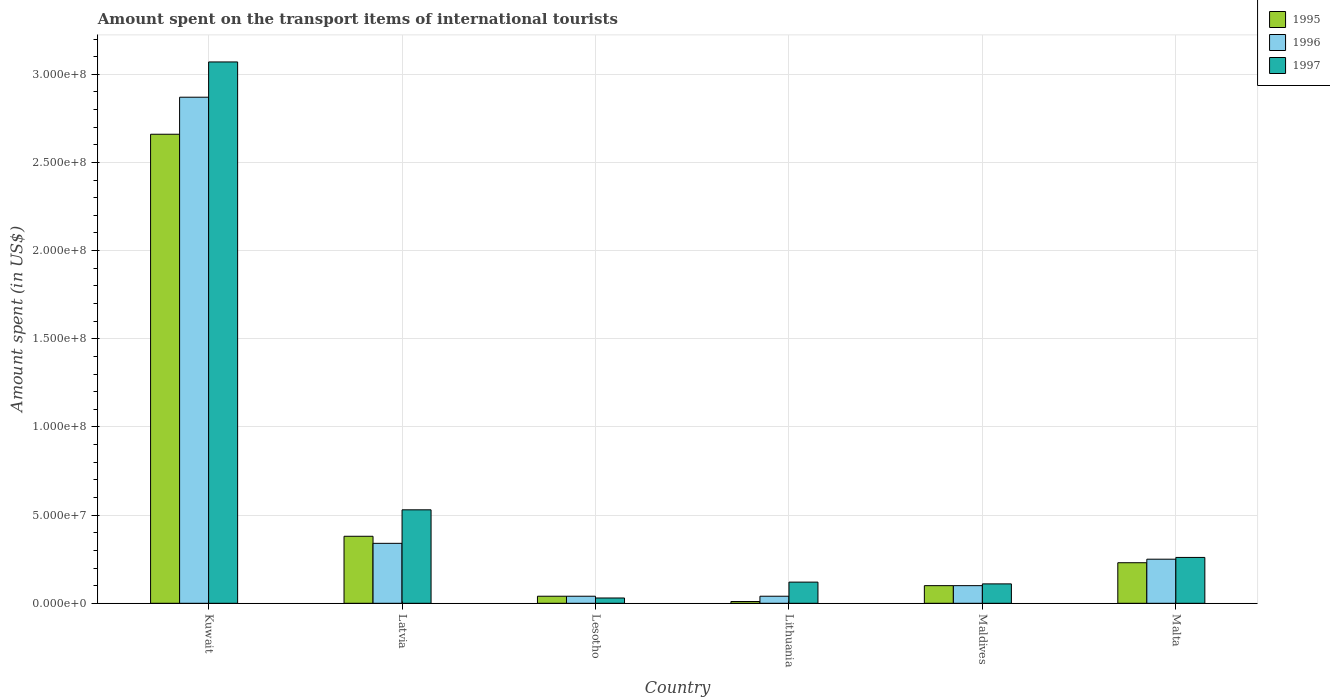How many different coloured bars are there?
Offer a very short reply. 3. How many groups of bars are there?
Your response must be concise. 6. Are the number of bars on each tick of the X-axis equal?
Give a very brief answer. Yes. How many bars are there on the 5th tick from the left?
Keep it short and to the point. 3. What is the label of the 6th group of bars from the left?
Provide a short and direct response. Malta. Across all countries, what is the maximum amount spent on the transport items of international tourists in 1995?
Make the answer very short. 2.66e+08. Across all countries, what is the minimum amount spent on the transport items of international tourists in 1997?
Keep it short and to the point. 3.00e+06. In which country was the amount spent on the transport items of international tourists in 1996 maximum?
Provide a succinct answer. Kuwait. In which country was the amount spent on the transport items of international tourists in 1995 minimum?
Offer a very short reply. Lithuania. What is the total amount spent on the transport items of international tourists in 1996 in the graph?
Provide a succinct answer. 3.64e+08. What is the difference between the amount spent on the transport items of international tourists in 1995 in Lithuania and that in Maldives?
Give a very brief answer. -9.00e+06. What is the difference between the amount spent on the transport items of international tourists in 1995 in Latvia and the amount spent on the transport items of international tourists in 1996 in Kuwait?
Provide a succinct answer. -2.49e+08. What is the average amount spent on the transport items of international tourists in 1995 per country?
Your answer should be very brief. 5.70e+07. What is the difference between the amount spent on the transport items of international tourists of/in 1996 and amount spent on the transport items of international tourists of/in 1995 in Maldives?
Your answer should be compact. 0. In how many countries, is the amount spent on the transport items of international tourists in 1997 greater than 190000000 US$?
Keep it short and to the point. 1. What is the ratio of the amount spent on the transport items of international tourists in 1996 in Latvia to that in Malta?
Offer a very short reply. 1.36. Is the difference between the amount spent on the transport items of international tourists in 1996 in Latvia and Lithuania greater than the difference between the amount spent on the transport items of international tourists in 1995 in Latvia and Lithuania?
Offer a terse response. No. What is the difference between the highest and the second highest amount spent on the transport items of international tourists in 1997?
Offer a terse response. 2.54e+08. What is the difference between the highest and the lowest amount spent on the transport items of international tourists in 1996?
Provide a short and direct response. 2.83e+08. Is the sum of the amount spent on the transport items of international tourists in 1997 in Latvia and Lesotho greater than the maximum amount spent on the transport items of international tourists in 1995 across all countries?
Provide a short and direct response. No. What does the 3rd bar from the left in Lesotho represents?
Offer a very short reply. 1997. What does the 3rd bar from the right in Maldives represents?
Provide a short and direct response. 1995. Is it the case that in every country, the sum of the amount spent on the transport items of international tourists in 1997 and amount spent on the transport items of international tourists in 1995 is greater than the amount spent on the transport items of international tourists in 1996?
Make the answer very short. Yes. How many bars are there?
Offer a very short reply. 18. Are all the bars in the graph horizontal?
Your answer should be compact. No. How many countries are there in the graph?
Provide a succinct answer. 6. What is the difference between two consecutive major ticks on the Y-axis?
Your answer should be compact. 5.00e+07. Are the values on the major ticks of Y-axis written in scientific E-notation?
Provide a short and direct response. Yes. Does the graph contain grids?
Ensure brevity in your answer.  Yes. Where does the legend appear in the graph?
Ensure brevity in your answer.  Top right. How are the legend labels stacked?
Provide a short and direct response. Vertical. What is the title of the graph?
Offer a terse response. Amount spent on the transport items of international tourists. What is the label or title of the X-axis?
Offer a very short reply. Country. What is the label or title of the Y-axis?
Your answer should be very brief. Amount spent (in US$). What is the Amount spent (in US$) of 1995 in Kuwait?
Your answer should be compact. 2.66e+08. What is the Amount spent (in US$) in 1996 in Kuwait?
Your response must be concise. 2.87e+08. What is the Amount spent (in US$) of 1997 in Kuwait?
Provide a short and direct response. 3.07e+08. What is the Amount spent (in US$) in 1995 in Latvia?
Keep it short and to the point. 3.80e+07. What is the Amount spent (in US$) in 1996 in Latvia?
Ensure brevity in your answer.  3.40e+07. What is the Amount spent (in US$) in 1997 in Latvia?
Give a very brief answer. 5.30e+07. What is the Amount spent (in US$) in 1995 in Lesotho?
Offer a very short reply. 4.00e+06. What is the Amount spent (in US$) in 1996 in Lesotho?
Your response must be concise. 4.00e+06. What is the Amount spent (in US$) in 1997 in Lesotho?
Your response must be concise. 3.00e+06. What is the Amount spent (in US$) of 1997 in Lithuania?
Your answer should be compact. 1.20e+07. What is the Amount spent (in US$) of 1995 in Maldives?
Your answer should be very brief. 1.00e+07. What is the Amount spent (in US$) of 1996 in Maldives?
Offer a terse response. 1.00e+07. What is the Amount spent (in US$) in 1997 in Maldives?
Give a very brief answer. 1.10e+07. What is the Amount spent (in US$) in 1995 in Malta?
Provide a short and direct response. 2.30e+07. What is the Amount spent (in US$) in 1996 in Malta?
Ensure brevity in your answer.  2.50e+07. What is the Amount spent (in US$) of 1997 in Malta?
Your answer should be compact. 2.60e+07. Across all countries, what is the maximum Amount spent (in US$) of 1995?
Your answer should be very brief. 2.66e+08. Across all countries, what is the maximum Amount spent (in US$) of 1996?
Provide a succinct answer. 2.87e+08. Across all countries, what is the maximum Amount spent (in US$) in 1997?
Make the answer very short. 3.07e+08. Across all countries, what is the minimum Amount spent (in US$) of 1996?
Offer a terse response. 4.00e+06. Across all countries, what is the minimum Amount spent (in US$) in 1997?
Provide a short and direct response. 3.00e+06. What is the total Amount spent (in US$) of 1995 in the graph?
Ensure brevity in your answer.  3.42e+08. What is the total Amount spent (in US$) of 1996 in the graph?
Ensure brevity in your answer.  3.64e+08. What is the total Amount spent (in US$) of 1997 in the graph?
Your answer should be compact. 4.12e+08. What is the difference between the Amount spent (in US$) in 1995 in Kuwait and that in Latvia?
Give a very brief answer. 2.28e+08. What is the difference between the Amount spent (in US$) in 1996 in Kuwait and that in Latvia?
Ensure brevity in your answer.  2.53e+08. What is the difference between the Amount spent (in US$) in 1997 in Kuwait and that in Latvia?
Your response must be concise. 2.54e+08. What is the difference between the Amount spent (in US$) in 1995 in Kuwait and that in Lesotho?
Give a very brief answer. 2.62e+08. What is the difference between the Amount spent (in US$) of 1996 in Kuwait and that in Lesotho?
Make the answer very short. 2.83e+08. What is the difference between the Amount spent (in US$) of 1997 in Kuwait and that in Lesotho?
Ensure brevity in your answer.  3.04e+08. What is the difference between the Amount spent (in US$) in 1995 in Kuwait and that in Lithuania?
Give a very brief answer. 2.65e+08. What is the difference between the Amount spent (in US$) of 1996 in Kuwait and that in Lithuania?
Offer a very short reply. 2.83e+08. What is the difference between the Amount spent (in US$) in 1997 in Kuwait and that in Lithuania?
Keep it short and to the point. 2.95e+08. What is the difference between the Amount spent (in US$) in 1995 in Kuwait and that in Maldives?
Your answer should be compact. 2.56e+08. What is the difference between the Amount spent (in US$) in 1996 in Kuwait and that in Maldives?
Provide a succinct answer. 2.77e+08. What is the difference between the Amount spent (in US$) of 1997 in Kuwait and that in Maldives?
Provide a short and direct response. 2.96e+08. What is the difference between the Amount spent (in US$) of 1995 in Kuwait and that in Malta?
Your response must be concise. 2.43e+08. What is the difference between the Amount spent (in US$) in 1996 in Kuwait and that in Malta?
Your answer should be compact. 2.62e+08. What is the difference between the Amount spent (in US$) of 1997 in Kuwait and that in Malta?
Provide a short and direct response. 2.81e+08. What is the difference between the Amount spent (in US$) of 1995 in Latvia and that in Lesotho?
Your answer should be compact. 3.40e+07. What is the difference between the Amount spent (in US$) of 1996 in Latvia and that in Lesotho?
Offer a terse response. 3.00e+07. What is the difference between the Amount spent (in US$) in 1995 in Latvia and that in Lithuania?
Ensure brevity in your answer.  3.70e+07. What is the difference between the Amount spent (in US$) of 1996 in Latvia and that in Lithuania?
Ensure brevity in your answer.  3.00e+07. What is the difference between the Amount spent (in US$) in 1997 in Latvia and that in Lithuania?
Your response must be concise. 4.10e+07. What is the difference between the Amount spent (in US$) in 1995 in Latvia and that in Maldives?
Make the answer very short. 2.80e+07. What is the difference between the Amount spent (in US$) of 1996 in Latvia and that in Maldives?
Offer a very short reply. 2.40e+07. What is the difference between the Amount spent (in US$) in 1997 in Latvia and that in Maldives?
Keep it short and to the point. 4.20e+07. What is the difference between the Amount spent (in US$) of 1995 in Latvia and that in Malta?
Make the answer very short. 1.50e+07. What is the difference between the Amount spent (in US$) in 1996 in Latvia and that in Malta?
Give a very brief answer. 9.00e+06. What is the difference between the Amount spent (in US$) of 1997 in Latvia and that in Malta?
Provide a short and direct response. 2.70e+07. What is the difference between the Amount spent (in US$) of 1995 in Lesotho and that in Lithuania?
Your answer should be very brief. 3.00e+06. What is the difference between the Amount spent (in US$) of 1996 in Lesotho and that in Lithuania?
Provide a succinct answer. 0. What is the difference between the Amount spent (in US$) of 1997 in Lesotho and that in Lithuania?
Your answer should be compact. -9.00e+06. What is the difference between the Amount spent (in US$) in 1995 in Lesotho and that in Maldives?
Ensure brevity in your answer.  -6.00e+06. What is the difference between the Amount spent (in US$) of 1996 in Lesotho and that in Maldives?
Your answer should be compact. -6.00e+06. What is the difference between the Amount spent (in US$) of 1997 in Lesotho and that in Maldives?
Give a very brief answer. -8.00e+06. What is the difference between the Amount spent (in US$) in 1995 in Lesotho and that in Malta?
Your response must be concise. -1.90e+07. What is the difference between the Amount spent (in US$) in 1996 in Lesotho and that in Malta?
Make the answer very short. -2.10e+07. What is the difference between the Amount spent (in US$) in 1997 in Lesotho and that in Malta?
Give a very brief answer. -2.30e+07. What is the difference between the Amount spent (in US$) in 1995 in Lithuania and that in Maldives?
Offer a terse response. -9.00e+06. What is the difference between the Amount spent (in US$) in 1996 in Lithuania and that in Maldives?
Your answer should be compact. -6.00e+06. What is the difference between the Amount spent (in US$) of 1997 in Lithuania and that in Maldives?
Ensure brevity in your answer.  1.00e+06. What is the difference between the Amount spent (in US$) of 1995 in Lithuania and that in Malta?
Provide a short and direct response. -2.20e+07. What is the difference between the Amount spent (in US$) of 1996 in Lithuania and that in Malta?
Give a very brief answer. -2.10e+07. What is the difference between the Amount spent (in US$) in 1997 in Lithuania and that in Malta?
Your answer should be compact. -1.40e+07. What is the difference between the Amount spent (in US$) of 1995 in Maldives and that in Malta?
Keep it short and to the point. -1.30e+07. What is the difference between the Amount spent (in US$) in 1996 in Maldives and that in Malta?
Offer a terse response. -1.50e+07. What is the difference between the Amount spent (in US$) in 1997 in Maldives and that in Malta?
Provide a short and direct response. -1.50e+07. What is the difference between the Amount spent (in US$) of 1995 in Kuwait and the Amount spent (in US$) of 1996 in Latvia?
Provide a short and direct response. 2.32e+08. What is the difference between the Amount spent (in US$) in 1995 in Kuwait and the Amount spent (in US$) in 1997 in Latvia?
Offer a very short reply. 2.13e+08. What is the difference between the Amount spent (in US$) in 1996 in Kuwait and the Amount spent (in US$) in 1997 in Latvia?
Provide a succinct answer. 2.34e+08. What is the difference between the Amount spent (in US$) of 1995 in Kuwait and the Amount spent (in US$) of 1996 in Lesotho?
Keep it short and to the point. 2.62e+08. What is the difference between the Amount spent (in US$) of 1995 in Kuwait and the Amount spent (in US$) of 1997 in Lesotho?
Your answer should be compact. 2.63e+08. What is the difference between the Amount spent (in US$) of 1996 in Kuwait and the Amount spent (in US$) of 1997 in Lesotho?
Keep it short and to the point. 2.84e+08. What is the difference between the Amount spent (in US$) in 1995 in Kuwait and the Amount spent (in US$) in 1996 in Lithuania?
Offer a very short reply. 2.62e+08. What is the difference between the Amount spent (in US$) in 1995 in Kuwait and the Amount spent (in US$) in 1997 in Lithuania?
Offer a very short reply. 2.54e+08. What is the difference between the Amount spent (in US$) in 1996 in Kuwait and the Amount spent (in US$) in 1997 in Lithuania?
Ensure brevity in your answer.  2.75e+08. What is the difference between the Amount spent (in US$) of 1995 in Kuwait and the Amount spent (in US$) of 1996 in Maldives?
Offer a very short reply. 2.56e+08. What is the difference between the Amount spent (in US$) of 1995 in Kuwait and the Amount spent (in US$) of 1997 in Maldives?
Offer a very short reply. 2.55e+08. What is the difference between the Amount spent (in US$) of 1996 in Kuwait and the Amount spent (in US$) of 1997 in Maldives?
Your answer should be very brief. 2.76e+08. What is the difference between the Amount spent (in US$) in 1995 in Kuwait and the Amount spent (in US$) in 1996 in Malta?
Offer a terse response. 2.41e+08. What is the difference between the Amount spent (in US$) of 1995 in Kuwait and the Amount spent (in US$) of 1997 in Malta?
Your answer should be very brief. 2.40e+08. What is the difference between the Amount spent (in US$) in 1996 in Kuwait and the Amount spent (in US$) in 1997 in Malta?
Your answer should be very brief. 2.61e+08. What is the difference between the Amount spent (in US$) in 1995 in Latvia and the Amount spent (in US$) in 1996 in Lesotho?
Your answer should be very brief. 3.40e+07. What is the difference between the Amount spent (in US$) of 1995 in Latvia and the Amount spent (in US$) of 1997 in Lesotho?
Provide a short and direct response. 3.50e+07. What is the difference between the Amount spent (in US$) of 1996 in Latvia and the Amount spent (in US$) of 1997 in Lesotho?
Your answer should be compact. 3.10e+07. What is the difference between the Amount spent (in US$) in 1995 in Latvia and the Amount spent (in US$) in 1996 in Lithuania?
Your response must be concise. 3.40e+07. What is the difference between the Amount spent (in US$) of 1995 in Latvia and the Amount spent (in US$) of 1997 in Lithuania?
Offer a very short reply. 2.60e+07. What is the difference between the Amount spent (in US$) of 1996 in Latvia and the Amount spent (in US$) of 1997 in Lithuania?
Offer a very short reply. 2.20e+07. What is the difference between the Amount spent (in US$) in 1995 in Latvia and the Amount spent (in US$) in 1996 in Maldives?
Keep it short and to the point. 2.80e+07. What is the difference between the Amount spent (in US$) of 1995 in Latvia and the Amount spent (in US$) of 1997 in Maldives?
Your answer should be compact. 2.70e+07. What is the difference between the Amount spent (in US$) of 1996 in Latvia and the Amount spent (in US$) of 1997 in Maldives?
Your answer should be compact. 2.30e+07. What is the difference between the Amount spent (in US$) of 1995 in Latvia and the Amount spent (in US$) of 1996 in Malta?
Keep it short and to the point. 1.30e+07. What is the difference between the Amount spent (in US$) of 1995 in Latvia and the Amount spent (in US$) of 1997 in Malta?
Offer a very short reply. 1.20e+07. What is the difference between the Amount spent (in US$) in 1996 in Latvia and the Amount spent (in US$) in 1997 in Malta?
Ensure brevity in your answer.  8.00e+06. What is the difference between the Amount spent (in US$) of 1995 in Lesotho and the Amount spent (in US$) of 1996 in Lithuania?
Provide a succinct answer. 0. What is the difference between the Amount spent (in US$) in 1995 in Lesotho and the Amount spent (in US$) in 1997 in Lithuania?
Keep it short and to the point. -8.00e+06. What is the difference between the Amount spent (in US$) in 1996 in Lesotho and the Amount spent (in US$) in 1997 in Lithuania?
Offer a very short reply. -8.00e+06. What is the difference between the Amount spent (in US$) in 1995 in Lesotho and the Amount spent (in US$) in 1996 in Maldives?
Provide a short and direct response. -6.00e+06. What is the difference between the Amount spent (in US$) in 1995 in Lesotho and the Amount spent (in US$) in 1997 in Maldives?
Make the answer very short. -7.00e+06. What is the difference between the Amount spent (in US$) in 1996 in Lesotho and the Amount spent (in US$) in 1997 in Maldives?
Ensure brevity in your answer.  -7.00e+06. What is the difference between the Amount spent (in US$) of 1995 in Lesotho and the Amount spent (in US$) of 1996 in Malta?
Make the answer very short. -2.10e+07. What is the difference between the Amount spent (in US$) in 1995 in Lesotho and the Amount spent (in US$) in 1997 in Malta?
Provide a short and direct response. -2.20e+07. What is the difference between the Amount spent (in US$) in 1996 in Lesotho and the Amount spent (in US$) in 1997 in Malta?
Keep it short and to the point. -2.20e+07. What is the difference between the Amount spent (in US$) in 1995 in Lithuania and the Amount spent (in US$) in 1996 in Maldives?
Your response must be concise. -9.00e+06. What is the difference between the Amount spent (in US$) of 1995 in Lithuania and the Amount spent (in US$) of 1997 in Maldives?
Ensure brevity in your answer.  -1.00e+07. What is the difference between the Amount spent (in US$) of 1996 in Lithuania and the Amount spent (in US$) of 1997 in Maldives?
Give a very brief answer. -7.00e+06. What is the difference between the Amount spent (in US$) of 1995 in Lithuania and the Amount spent (in US$) of 1996 in Malta?
Provide a succinct answer. -2.40e+07. What is the difference between the Amount spent (in US$) in 1995 in Lithuania and the Amount spent (in US$) in 1997 in Malta?
Your response must be concise. -2.50e+07. What is the difference between the Amount spent (in US$) in 1996 in Lithuania and the Amount spent (in US$) in 1997 in Malta?
Your answer should be very brief. -2.20e+07. What is the difference between the Amount spent (in US$) of 1995 in Maldives and the Amount spent (in US$) of 1996 in Malta?
Your answer should be compact. -1.50e+07. What is the difference between the Amount spent (in US$) of 1995 in Maldives and the Amount spent (in US$) of 1997 in Malta?
Your answer should be compact. -1.60e+07. What is the difference between the Amount spent (in US$) in 1996 in Maldives and the Amount spent (in US$) in 1997 in Malta?
Offer a very short reply. -1.60e+07. What is the average Amount spent (in US$) of 1995 per country?
Your answer should be compact. 5.70e+07. What is the average Amount spent (in US$) of 1996 per country?
Make the answer very short. 6.07e+07. What is the average Amount spent (in US$) in 1997 per country?
Offer a terse response. 6.87e+07. What is the difference between the Amount spent (in US$) of 1995 and Amount spent (in US$) of 1996 in Kuwait?
Offer a very short reply. -2.10e+07. What is the difference between the Amount spent (in US$) in 1995 and Amount spent (in US$) in 1997 in Kuwait?
Make the answer very short. -4.10e+07. What is the difference between the Amount spent (in US$) in 1996 and Amount spent (in US$) in 1997 in Kuwait?
Offer a terse response. -2.00e+07. What is the difference between the Amount spent (in US$) in 1995 and Amount spent (in US$) in 1997 in Latvia?
Provide a succinct answer. -1.50e+07. What is the difference between the Amount spent (in US$) of 1996 and Amount spent (in US$) of 1997 in Latvia?
Ensure brevity in your answer.  -1.90e+07. What is the difference between the Amount spent (in US$) in 1995 and Amount spent (in US$) in 1997 in Lesotho?
Make the answer very short. 1.00e+06. What is the difference between the Amount spent (in US$) in 1996 and Amount spent (in US$) in 1997 in Lesotho?
Ensure brevity in your answer.  1.00e+06. What is the difference between the Amount spent (in US$) in 1995 and Amount spent (in US$) in 1997 in Lithuania?
Make the answer very short. -1.10e+07. What is the difference between the Amount spent (in US$) of 1996 and Amount spent (in US$) of 1997 in Lithuania?
Your answer should be very brief. -8.00e+06. What is the difference between the Amount spent (in US$) of 1995 and Amount spent (in US$) of 1996 in Maldives?
Your response must be concise. 0. What is the difference between the Amount spent (in US$) in 1995 and Amount spent (in US$) in 1997 in Maldives?
Provide a short and direct response. -1.00e+06. What is the ratio of the Amount spent (in US$) of 1995 in Kuwait to that in Latvia?
Make the answer very short. 7. What is the ratio of the Amount spent (in US$) of 1996 in Kuwait to that in Latvia?
Give a very brief answer. 8.44. What is the ratio of the Amount spent (in US$) in 1997 in Kuwait to that in Latvia?
Make the answer very short. 5.79. What is the ratio of the Amount spent (in US$) in 1995 in Kuwait to that in Lesotho?
Ensure brevity in your answer.  66.5. What is the ratio of the Amount spent (in US$) in 1996 in Kuwait to that in Lesotho?
Make the answer very short. 71.75. What is the ratio of the Amount spent (in US$) in 1997 in Kuwait to that in Lesotho?
Keep it short and to the point. 102.33. What is the ratio of the Amount spent (in US$) of 1995 in Kuwait to that in Lithuania?
Your answer should be compact. 266. What is the ratio of the Amount spent (in US$) in 1996 in Kuwait to that in Lithuania?
Offer a very short reply. 71.75. What is the ratio of the Amount spent (in US$) of 1997 in Kuwait to that in Lithuania?
Your answer should be compact. 25.58. What is the ratio of the Amount spent (in US$) of 1995 in Kuwait to that in Maldives?
Provide a succinct answer. 26.6. What is the ratio of the Amount spent (in US$) of 1996 in Kuwait to that in Maldives?
Your answer should be compact. 28.7. What is the ratio of the Amount spent (in US$) of 1997 in Kuwait to that in Maldives?
Provide a succinct answer. 27.91. What is the ratio of the Amount spent (in US$) of 1995 in Kuwait to that in Malta?
Offer a very short reply. 11.57. What is the ratio of the Amount spent (in US$) of 1996 in Kuwait to that in Malta?
Your answer should be compact. 11.48. What is the ratio of the Amount spent (in US$) in 1997 in Kuwait to that in Malta?
Provide a short and direct response. 11.81. What is the ratio of the Amount spent (in US$) of 1996 in Latvia to that in Lesotho?
Provide a succinct answer. 8.5. What is the ratio of the Amount spent (in US$) of 1997 in Latvia to that in Lesotho?
Offer a terse response. 17.67. What is the ratio of the Amount spent (in US$) of 1995 in Latvia to that in Lithuania?
Keep it short and to the point. 38. What is the ratio of the Amount spent (in US$) of 1996 in Latvia to that in Lithuania?
Your answer should be compact. 8.5. What is the ratio of the Amount spent (in US$) in 1997 in Latvia to that in Lithuania?
Offer a terse response. 4.42. What is the ratio of the Amount spent (in US$) of 1997 in Latvia to that in Maldives?
Provide a succinct answer. 4.82. What is the ratio of the Amount spent (in US$) in 1995 in Latvia to that in Malta?
Your response must be concise. 1.65. What is the ratio of the Amount spent (in US$) in 1996 in Latvia to that in Malta?
Keep it short and to the point. 1.36. What is the ratio of the Amount spent (in US$) in 1997 in Latvia to that in Malta?
Your answer should be very brief. 2.04. What is the ratio of the Amount spent (in US$) of 1997 in Lesotho to that in Lithuania?
Offer a terse response. 0.25. What is the ratio of the Amount spent (in US$) in 1996 in Lesotho to that in Maldives?
Ensure brevity in your answer.  0.4. What is the ratio of the Amount spent (in US$) in 1997 in Lesotho to that in Maldives?
Offer a terse response. 0.27. What is the ratio of the Amount spent (in US$) in 1995 in Lesotho to that in Malta?
Provide a short and direct response. 0.17. What is the ratio of the Amount spent (in US$) of 1996 in Lesotho to that in Malta?
Make the answer very short. 0.16. What is the ratio of the Amount spent (in US$) of 1997 in Lesotho to that in Malta?
Keep it short and to the point. 0.12. What is the ratio of the Amount spent (in US$) in 1997 in Lithuania to that in Maldives?
Offer a terse response. 1.09. What is the ratio of the Amount spent (in US$) in 1995 in Lithuania to that in Malta?
Make the answer very short. 0.04. What is the ratio of the Amount spent (in US$) in 1996 in Lithuania to that in Malta?
Offer a terse response. 0.16. What is the ratio of the Amount spent (in US$) of 1997 in Lithuania to that in Malta?
Your response must be concise. 0.46. What is the ratio of the Amount spent (in US$) of 1995 in Maldives to that in Malta?
Your response must be concise. 0.43. What is the ratio of the Amount spent (in US$) in 1996 in Maldives to that in Malta?
Your response must be concise. 0.4. What is the ratio of the Amount spent (in US$) of 1997 in Maldives to that in Malta?
Keep it short and to the point. 0.42. What is the difference between the highest and the second highest Amount spent (in US$) of 1995?
Ensure brevity in your answer.  2.28e+08. What is the difference between the highest and the second highest Amount spent (in US$) in 1996?
Your answer should be very brief. 2.53e+08. What is the difference between the highest and the second highest Amount spent (in US$) in 1997?
Provide a succinct answer. 2.54e+08. What is the difference between the highest and the lowest Amount spent (in US$) in 1995?
Make the answer very short. 2.65e+08. What is the difference between the highest and the lowest Amount spent (in US$) of 1996?
Give a very brief answer. 2.83e+08. What is the difference between the highest and the lowest Amount spent (in US$) of 1997?
Your answer should be compact. 3.04e+08. 